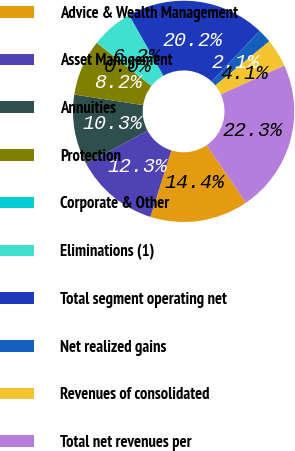<chart> <loc_0><loc_0><loc_500><loc_500><pie_chart><fcel>Advice & Wealth Management<fcel>Asset Management<fcel>Annuities<fcel>Protection<fcel>Corporate & Other<fcel>Eliminations (1)<fcel>Total segment operating net<fcel>Net realized gains<fcel>Revenues of consolidated<fcel>Total net revenues per<nl><fcel>14.36%<fcel>12.31%<fcel>10.26%<fcel>8.21%<fcel>0.01%<fcel>6.16%<fcel>20.23%<fcel>2.06%<fcel>4.11%<fcel>22.28%<nl></chart> 